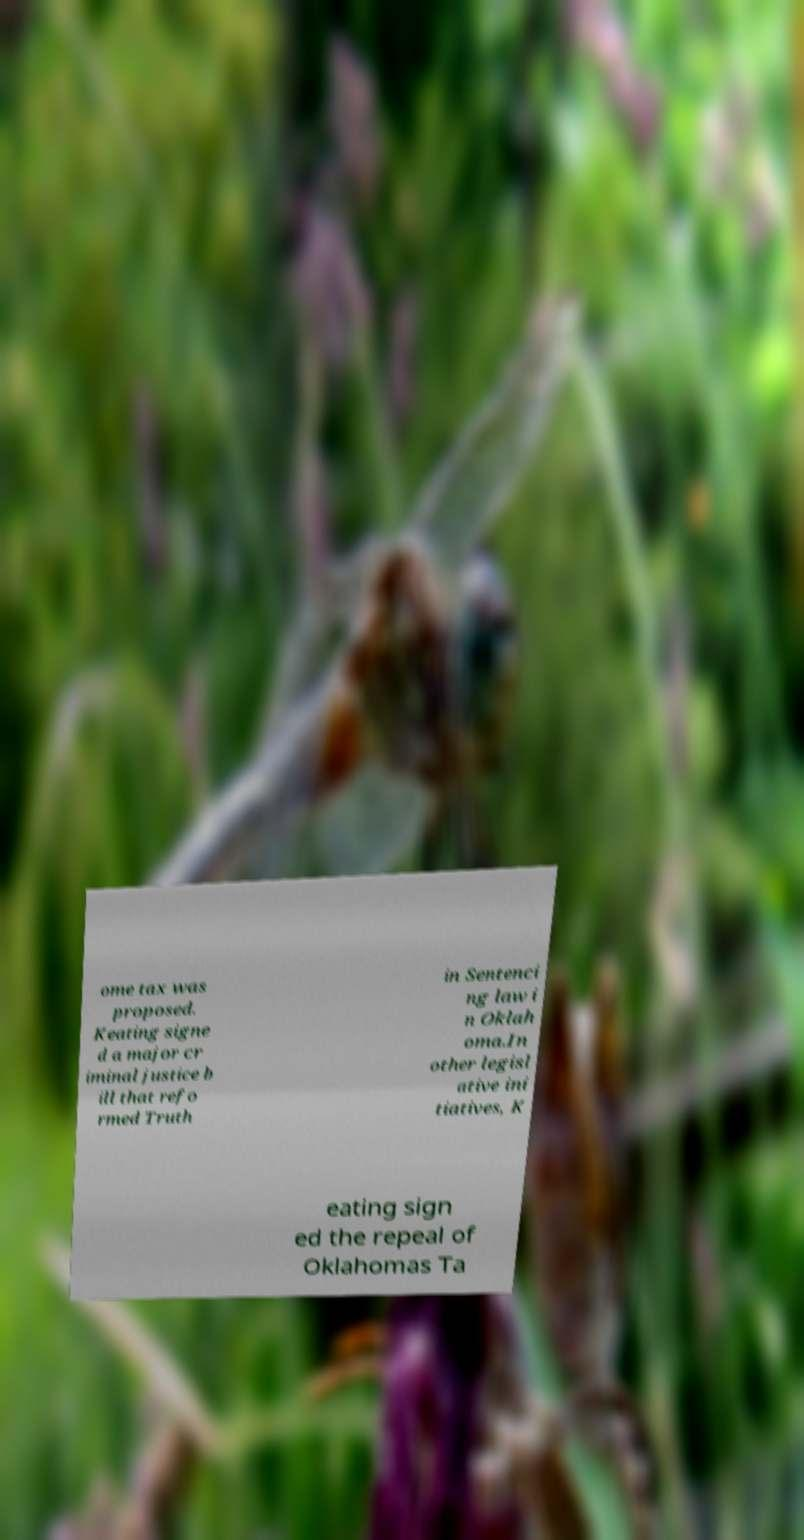Could you extract and type out the text from this image? ome tax was proposed. Keating signe d a major cr iminal justice b ill that refo rmed Truth in Sentenci ng law i n Oklah oma.In other legisl ative ini tiatives, K eating sign ed the repeal of Oklahomas Ta 